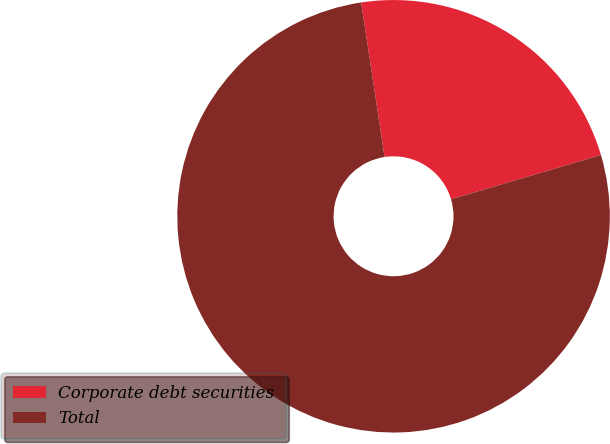Convert chart. <chart><loc_0><loc_0><loc_500><loc_500><pie_chart><fcel>Corporate debt securities<fcel>Total<nl><fcel>22.82%<fcel>77.18%<nl></chart> 